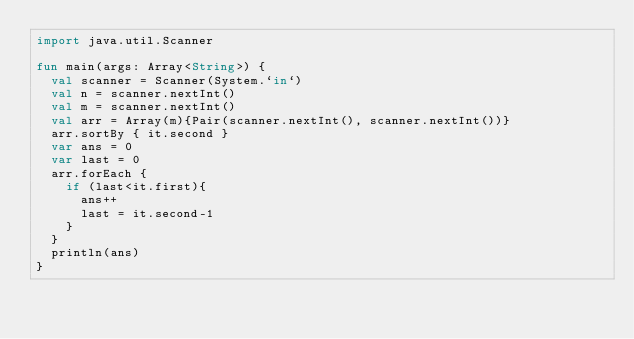Convert code to text. <code><loc_0><loc_0><loc_500><loc_500><_Kotlin_>import java.util.Scanner

fun main(args: Array<String>) {
	val scanner = Scanner(System.`in`)
	val n = scanner.nextInt()
	val m = scanner.nextInt()
	val arr = Array(m){Pair(scanner.nextInt(), scanner.nextInt())}
	arr.sortBy { it.second }
	var ans = 0
	var last = 0
	arr.forEach {
		if (last<it.first){
			ans++
			last = it.second-1
		}
	}
	println(ans)
}</code> 